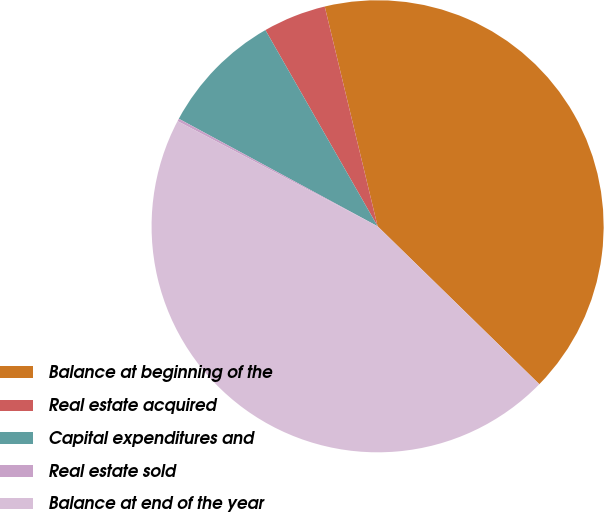Convert chart to OTSL. <chart><loc_0><loc_0><loc_500><loc_500><pie_chart><fcel>Balance at beginning of the<fcel>Real estate acquired<fcel>Capital expenditures and<fcel>Real estate sold<fcel>Balance at end of the year<nl><fcel>41.07%<fcel>4.51%<fcel>8.84%<fcel>0.19%<fcel>45.39%<nl></chart> 